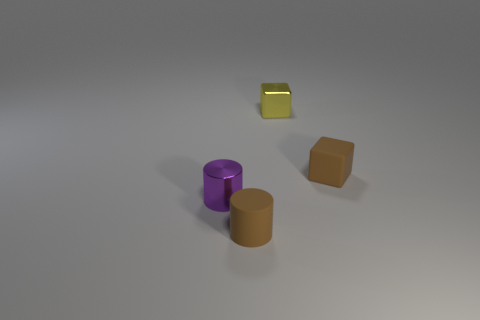Add 1 small purple metallic cylinders. How many objects exist? 5 Subtract 2 blocks. How many blocks are left? 0 Add 3 yellow things. How many yellow things are left? 4 Add 4 tiny gray metal blocks. How many tiny gray metal blocks exist? 4 Subtract 1 purple cylinders. How many objects are left? 3 Subtract all red cubes. Subtract all blue spheres. How many cubes are left? 2 Subtract all purple cubes. How many brown cylinders are left? 1 Subtract all small cyan matte cylinders. Subtract all tiny brown matte cylinders. How many objects are left? 3 